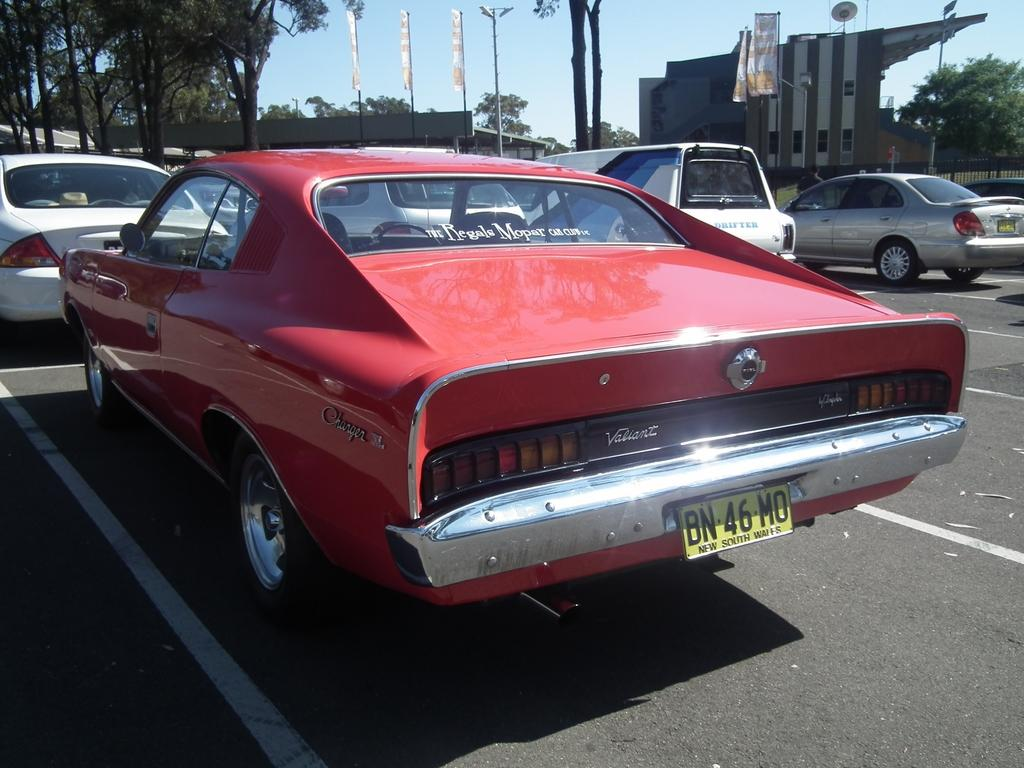Provide a one-sentence caption for the provided image. a license plate that has the letters BN on the back of it. 